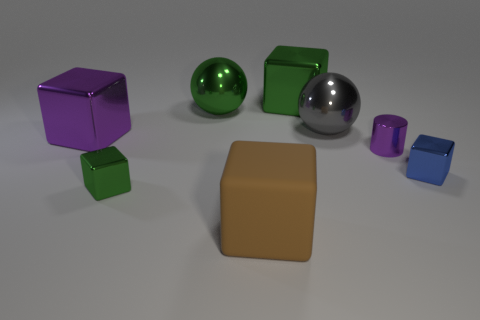How many big metal blocks are both to the right of the rubber block and on the left side of the large rubber object? After examining the spatial arrangement of the objects in the image, it appears that there is one large metal block that satisfies both conditions of being to the right of the rubber block and on the left side of the large rubber object. 